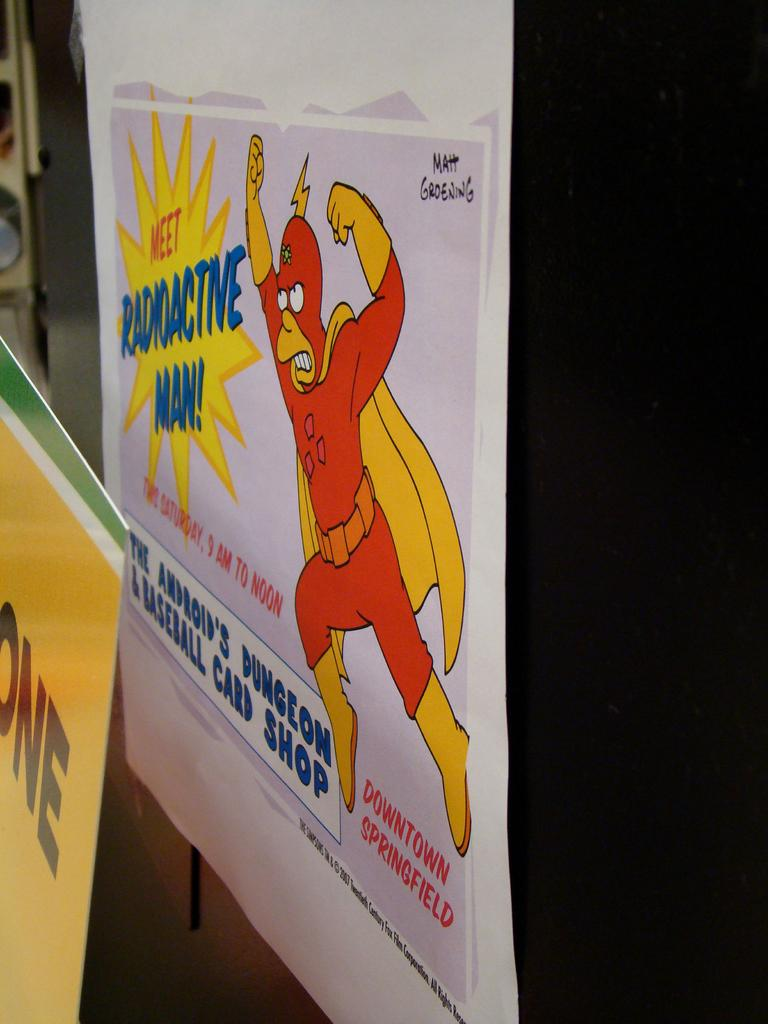<image>
Summarize the visual content of the image. A sign advertises the chance to meet radioactive man. 